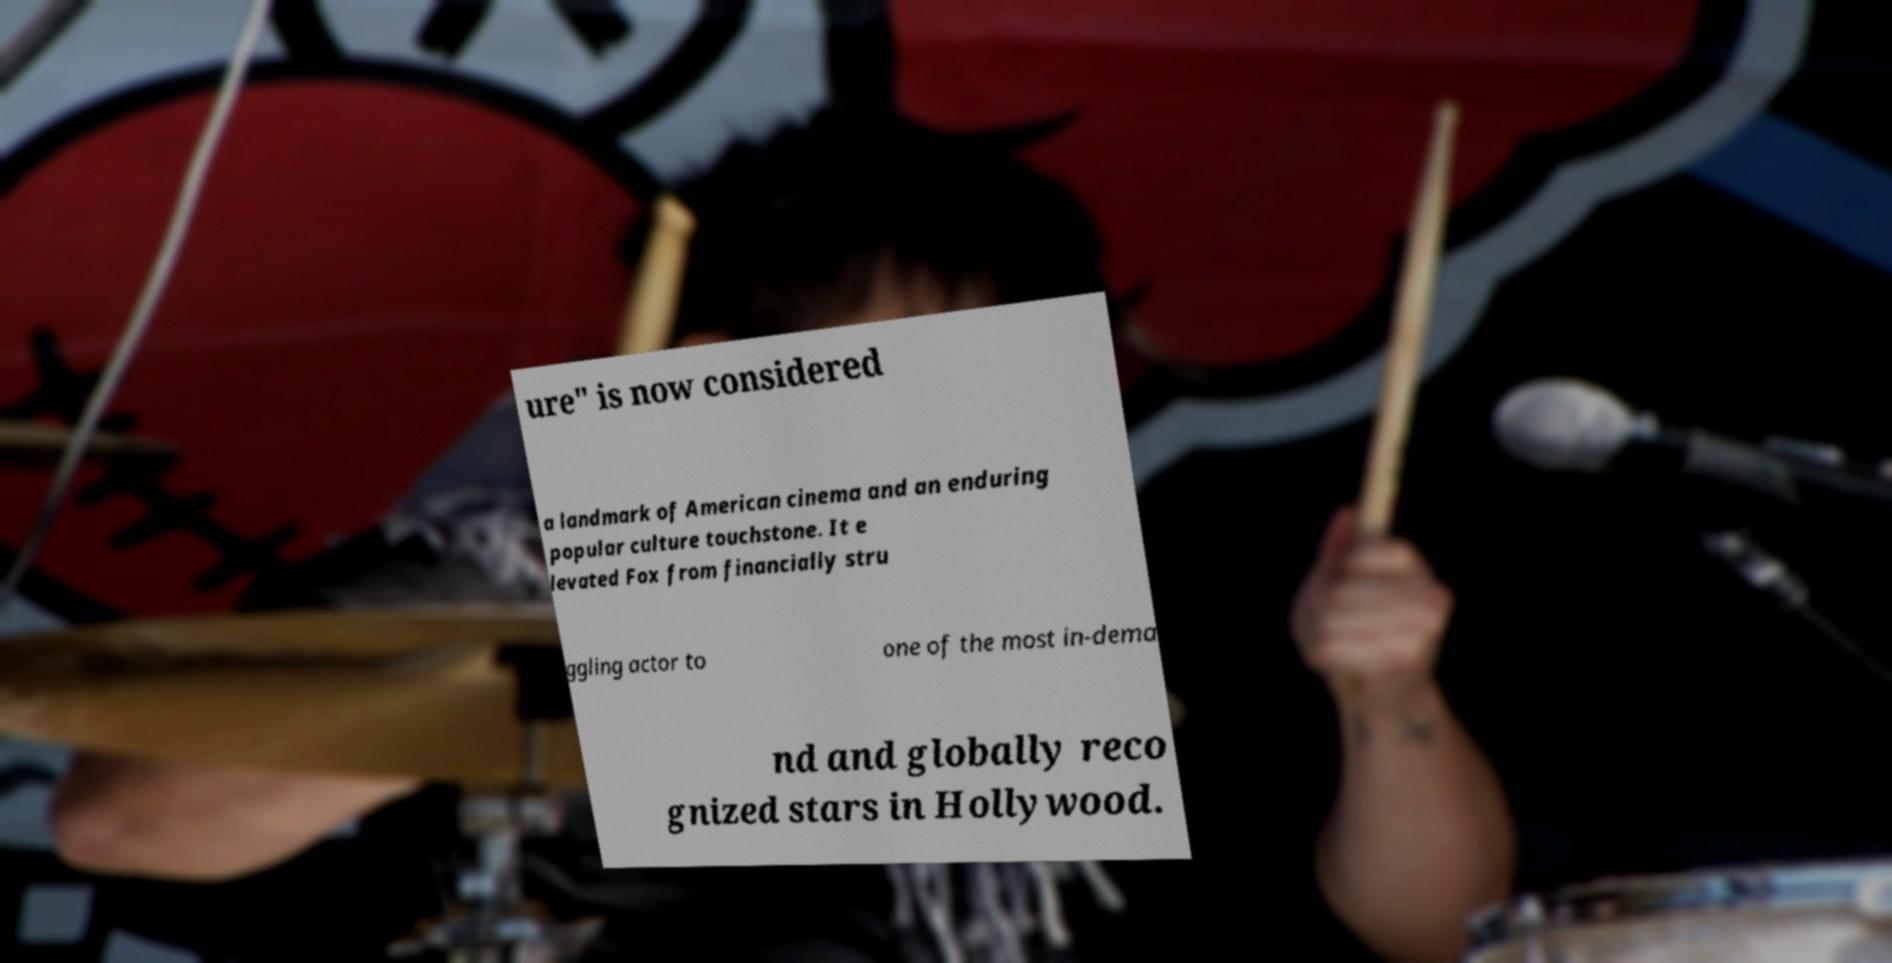Can you accurately transcribe the text from the provided image for me? ure" is now considered a landmark of American cinema and an enduring popular culture touchstone. It e levated Fox from financially stru ggling actor to one of the most in-dema nd and globally reco gnized stars in Hollywood. 